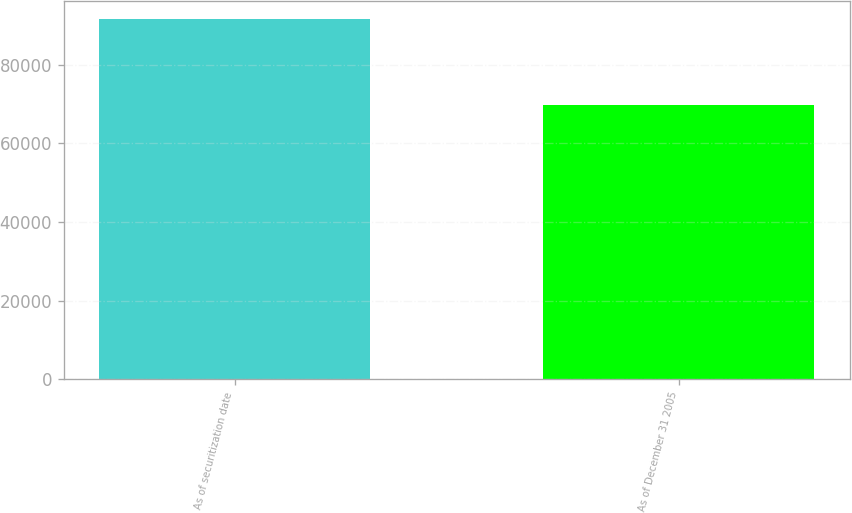<chart> <loc_0><loc_0><loc_500><loc_500><bar_chart><fcel>As of securitization date<fcel>As of December 31 2005<nl><fcel>91705<fcel>69809<nl></chart> 